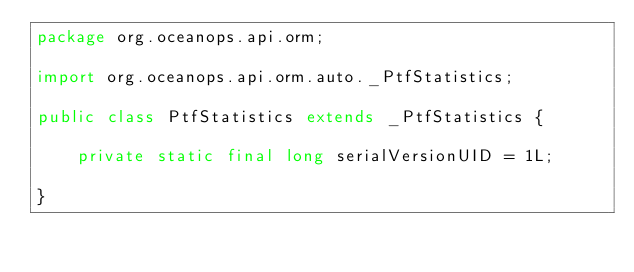<code> <loc_0><loc_0><loc_500><loc_500><_Java_>package org.oceanops.api.orm;

import org.oceanops.api.orm.auto._PtfStatistics;

public class PtfStatistics extends _PtfStatistics {

    private static final long serialVersionUID = 1L;

}
</code> 